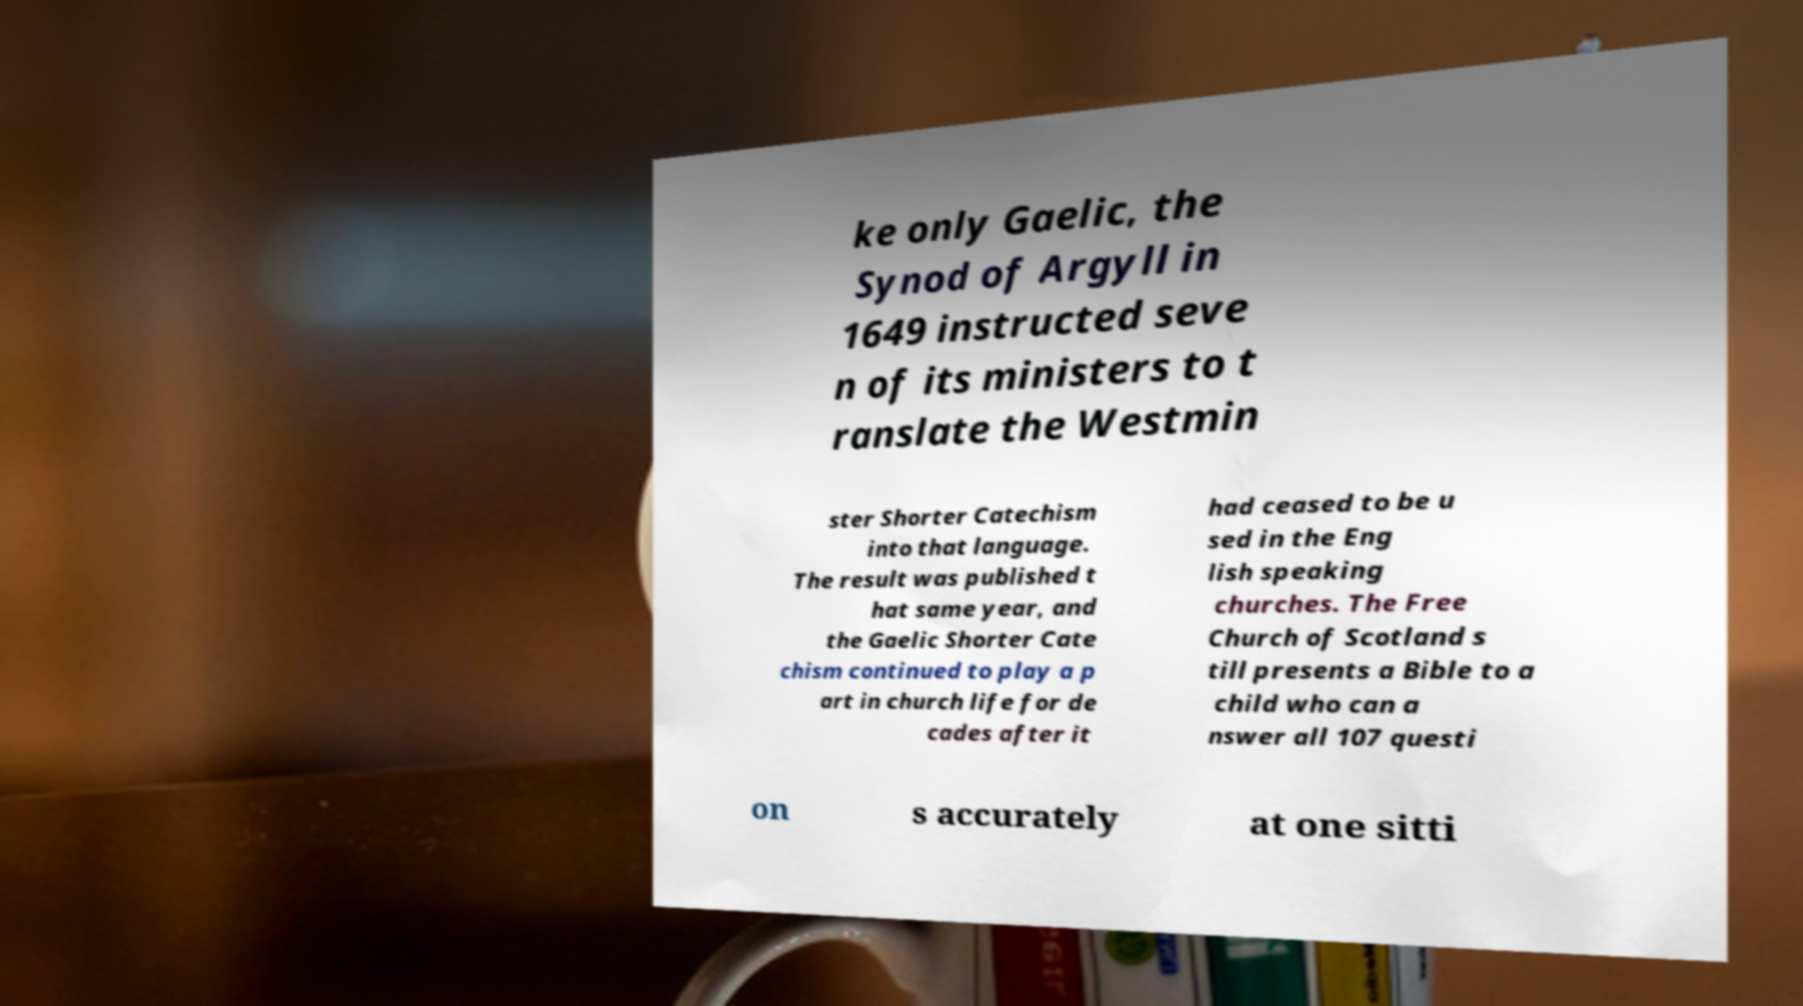Could you extract and type out the text from this image? ke only Gaelic, the Synod of Argyll in 1649 instructed seve n of its ministers to t ranslate the Westmin ster Shorter Catechism into that language. The result was published t hat same year, and the Gaelic Shorter Cate chism continued to play a p art in church life for de cades after it had ceased to be u sed in the Eng lish speaking churches. The Free Church of Scotland s till presents a Bible to a child who can a nswer all 107 questi on s accurately at one sitti 